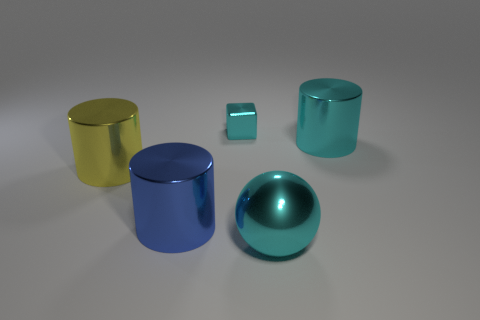Add 1 red matte blocks. How many objects exist? 6 Subtract all cubes. How many objects are left? 4 Add 3 big blue cylinders. How many big blue cylinders exist? 4 Subtract 0 brown cubes. How many objects are left? 5 Subtract all tiny metallic cubes. Subtract all tiny purple matte cubes. How many objects are left? 4 Add 4 big objects. How many big objects are left? 8 